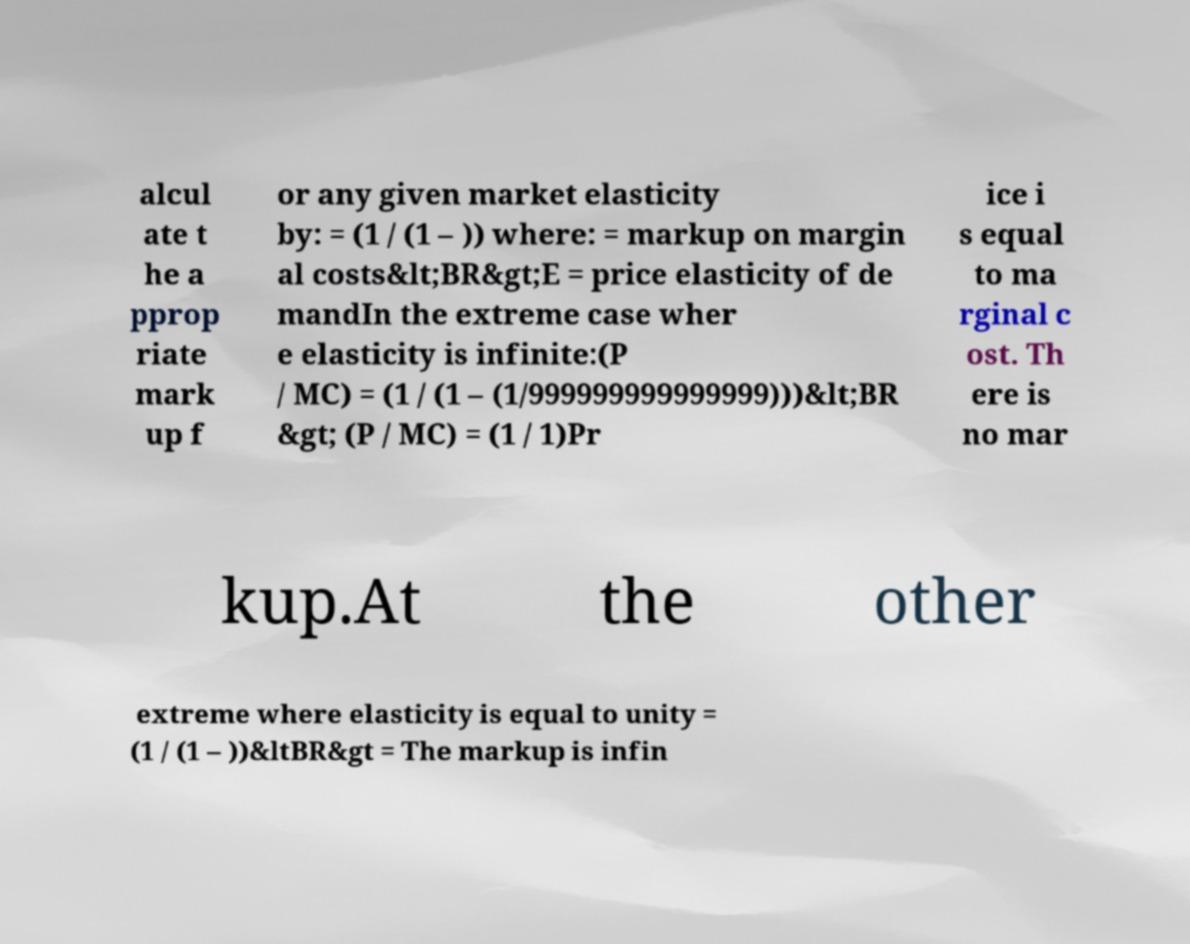Can you accurately transcribe the text from the provided image for me? alcul ate t he a pprop riate mark up f or any given market elasticity by: = (1 / (1 – )) where: = markup on margin al costs&lt;BR&gt;E = price elasticity of de mandIn the extreme case wher e elasticity is infinite:(P / MC) = (1 / (1 – (1/999999999999999)))&lt;BR &gt; (P / MC) = (1 / 1)Pr ice i s equal to ma rginal c ost. Th ere is no mar kup.At the other extreme where elasticity is equal to unity = (1 / (1 – ))&ltBR&gt = The markup is infin 